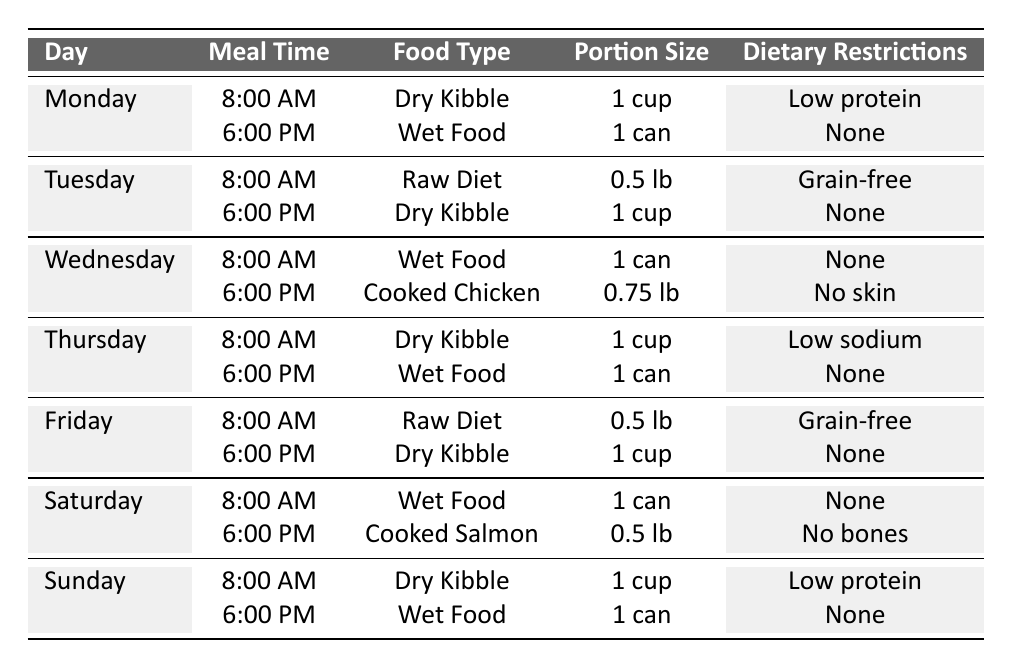What is the portion size for Wet Food on Monday evening? The table shows the meal schedule for Monday, and for the 6:00 PM meal, the food type is Wet Food with a portion size of 1 can.
Answer: 1 can How many meals are served on Wednesdays? The table lists two meal times for Wednesday: 8:00 AM and 6:00 PM, indicating there are two meals served that day.
Answer: 2 What dietary restriction is listed for the Dry Kibble served on Sundays? Referring to the Sunday entry in the table, it shows the Dry Kibble served at 8:00 AM has a dietary restriction of Low protein.
Answer: Low protein On which days is Wet Food served in the morning? Wet Food is served in the morning on Wednesday and Saturday, as seen in the table under the breakfast time entries for those days.
Answer: Wednesday and Saturday What type of food is served for the second meal on Friday? According to the table, Friday's second meal at 6:00 PM consists of Dry Kibble.
Answer: Dry Kibble Is there a day when the pet eats Raw Diet twice? The table indicates that Raw Diet is served only on Tuesday and Friday, both at 8:00 AM, so it is not eaten twice in one day.
Answer: No What percentage of the meals served on weekends is Wet Food? On Saturday and Sunday, there are four meals in total. Wet Food is served on Saturday morning and Sunday evening, amounting to two Wet Food meals. The percentage is (2/4) * 100 = 50%.
Answer: 50% Which meal has the largest portion size? Review the portion sizes listed: Wet Food and Dry Kibble have portion sizes of 1 can, while cooked meals like Cooked Chicken (0.75 lb) and Cooked Salmon (0.5 lb) are smaller. Wet Food meals' portion size is the largest at 1 can.
Answer: 1 can What is the total portion size of Dry Kibble given during the week? Dry Kibble appears on Monday (1 cup), Tuesday (1 cup), Thursday (1 cup), Friday (1 cup), and Sunday (1 cup). Summing these gives 5 cups total (1 + 1 + 1 + 1 + 1 = 5).
Answer: 5 cups On which day is Cooked Chicken served, and what is its portion size? According to the table, Cooked Chicken is served on Wednesday at 6:00 PM with a portion size of 0.75 lb.
Answer: Wednesday, 0.75 lb 